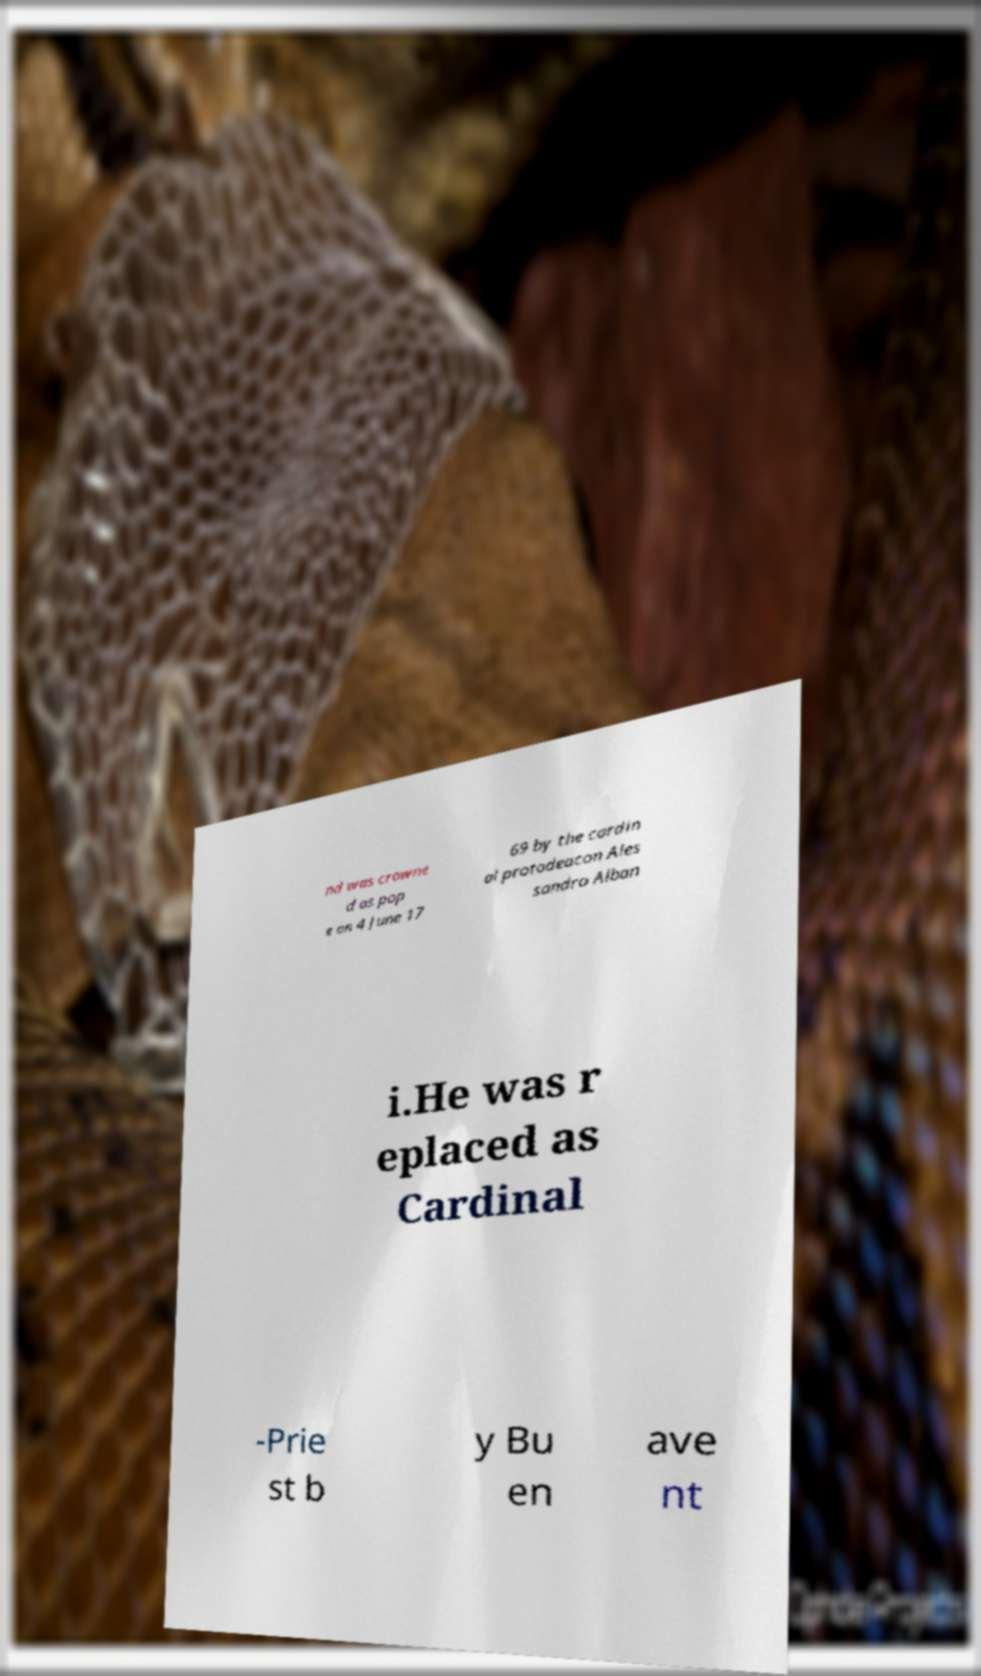Please read and relay the text visible in this image. What does it say? nd was crowne d as pop e on 4 June 17 69 by the cardin al protodeacon Ales sandro Alban i.He was r eplaced as Cardinal -Prie st b y Bu en ave nt 